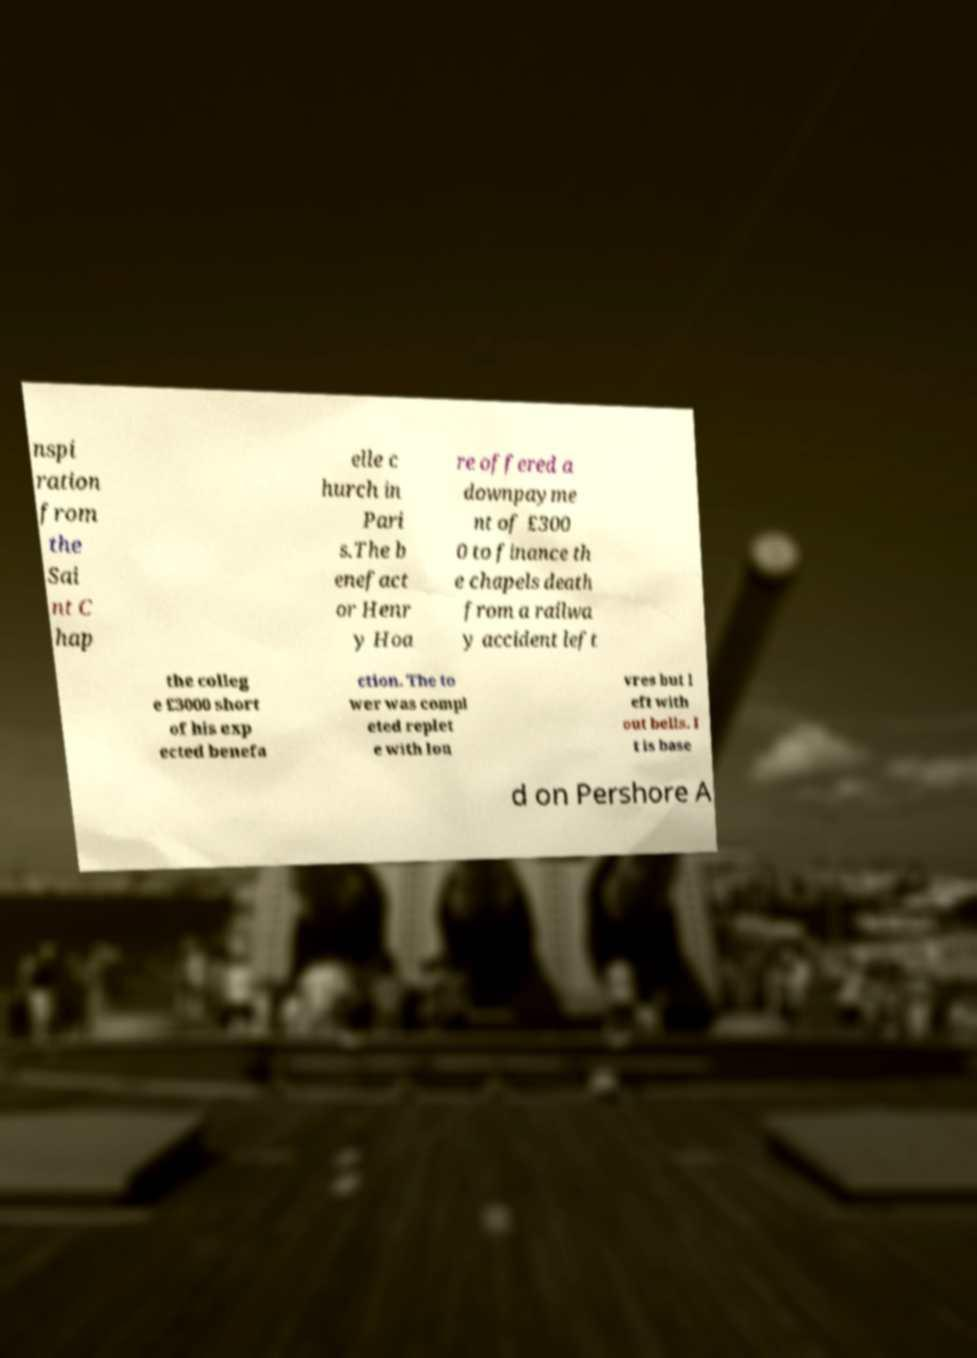There's text embedded in this image that I need extracted. Can you transcribe it verbatim? nspi ration from the Sai nt C hap elle c hurch in Pari s.The b enefact or Henr y Hoa re offered a downpayme nt of £300 0 to finance th e chapels death from a railwa y accident left the colleg e £3000 short of his exp ected benefa ction. The to wer was compl eted replet e with lou vres but l eft with out bells. I t is base d on Pershore A 